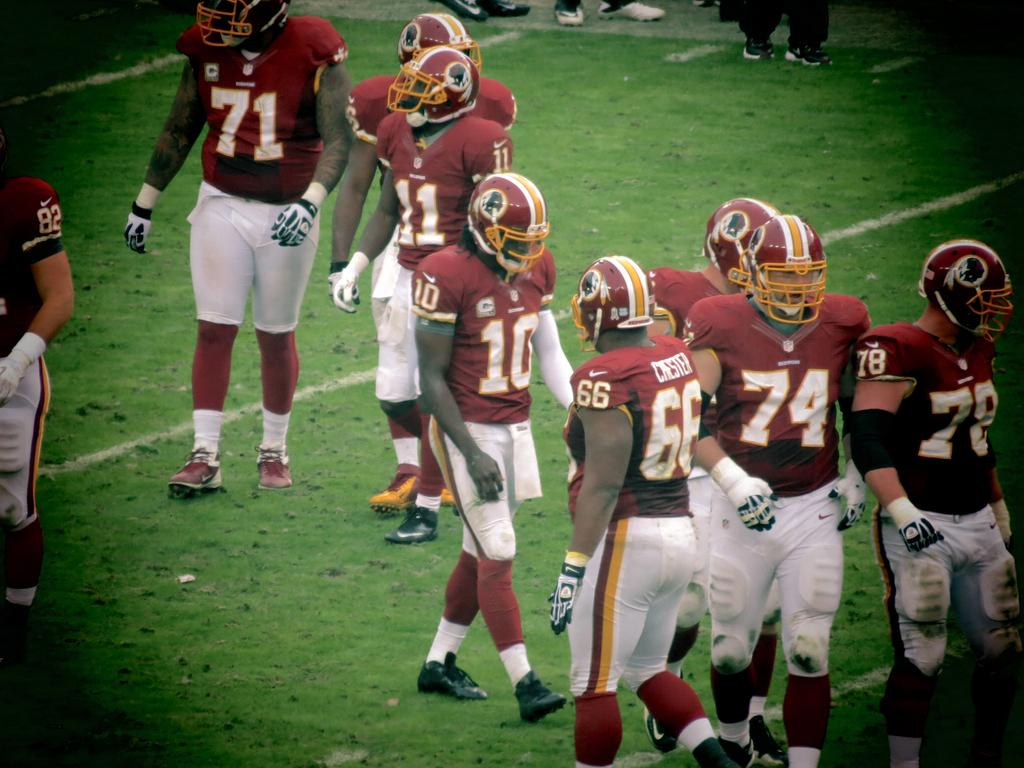Where was the image taken? The image was taken in a playground. What are the people in the image doing? There is a group of people walking on the grass in the image. What color elements can be seen in the corners of the image? There are black color elements in the corners of the image. Can you see any bananas being peeled by the people in the image? There are no bananas or any peeling activity visible in the image. What type of watch is the person wearing in the image? There are no watches or any accessories visible on the people in the image. 